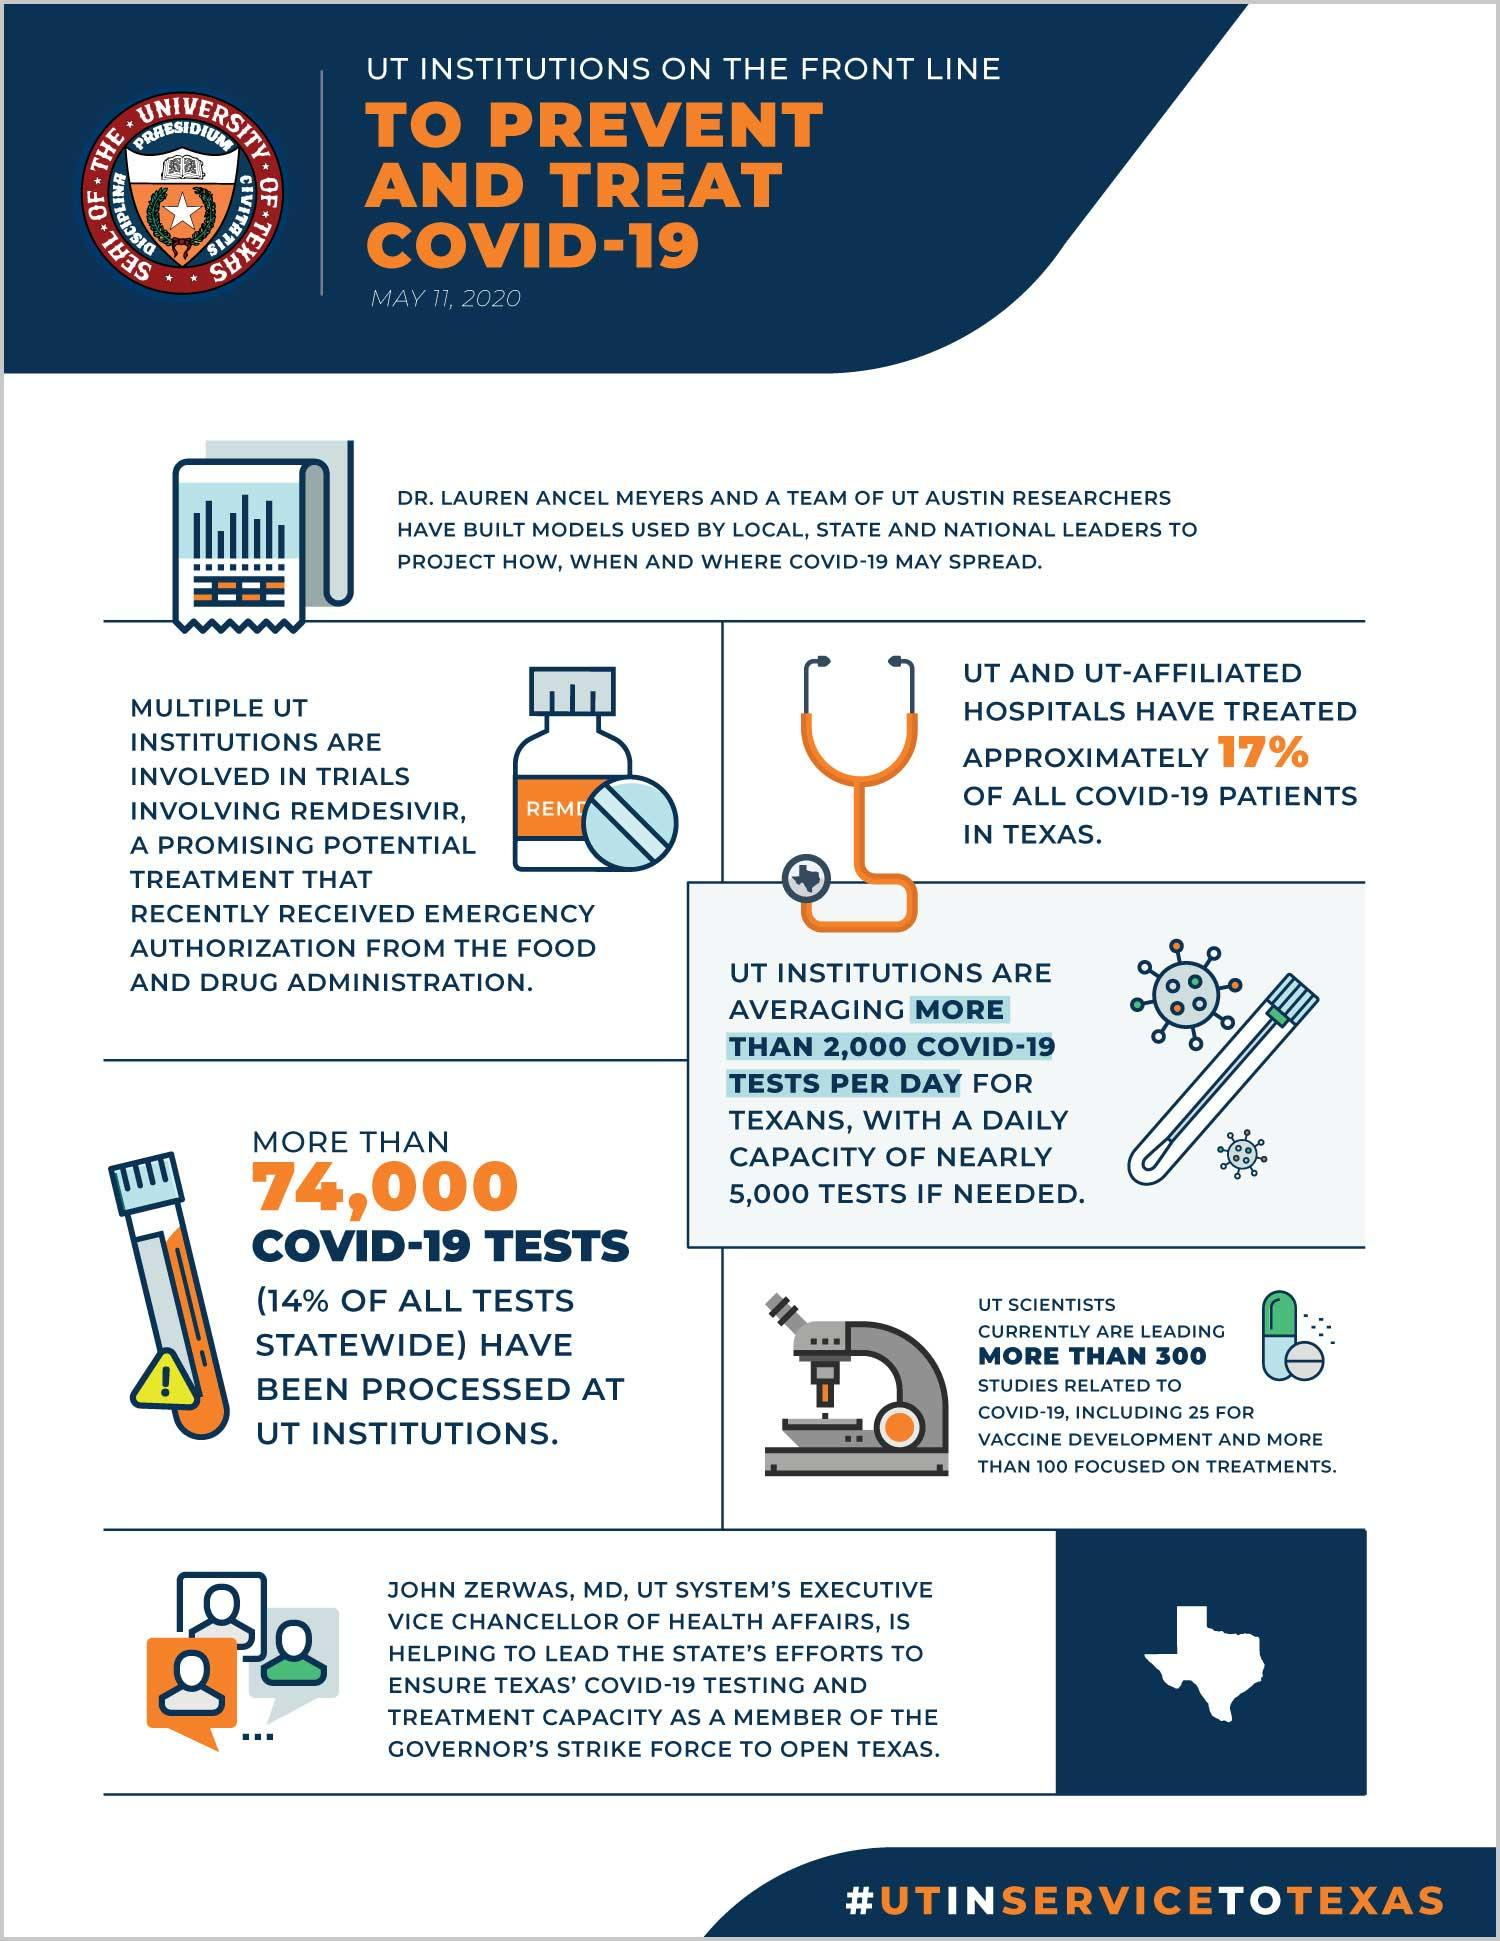Draw attention to some important aspects in this diagram. The drug "Remdesivir" has received emergency authorization from the Food and Drug Administration (FDA) in response to the ongoing COVID-19 pandemic. Approximately 25 studies on vaccine development have been conducted by UT scientists. UT and its affiliated hospitals are responsible for the treatment of approximately 17% of COVID-19 patients in Texas. According to the provided information, approximately 100 out of 300 studies conducted by UT scientists have focused on COVID-19 treatments. 